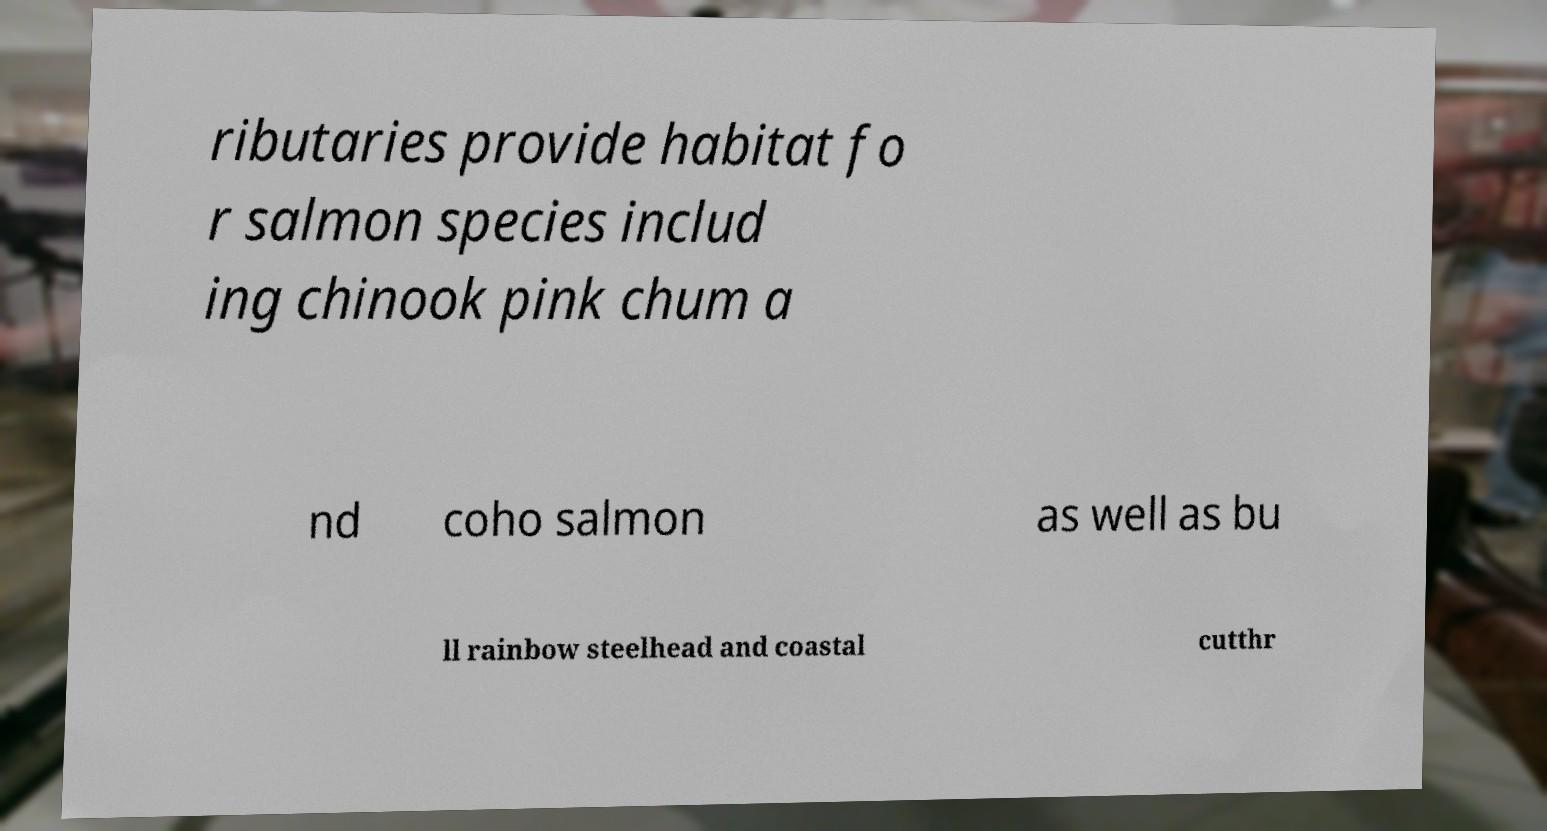What messages or text are displayed in this image? I need them in a readable, typed format. ributaries provide habitat fo r salmon species includ ing chinook pink chum a nd coho salmon as well as bu ll rainbow steelhead and coastal cutthr 